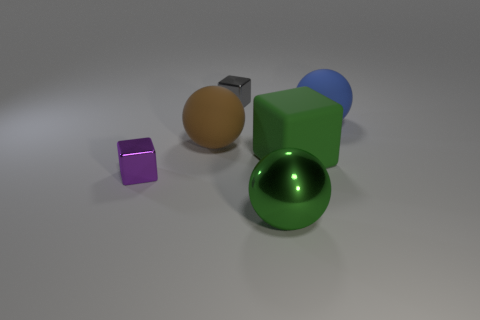Add 4 big red balls. How many objects exist? 10 Subtract all big green rubber blocks. How many blocks are left? 2 Subtract 2 blocks. How many blocks are left? 1 Subtract all gray blocks. Subtract all yellow cylinders. How many blocks are left? 2 Subtract all large cubes. Subtract all tiny purple things. How many objects are left? 4 Add 5 tiny shiny things. How many tiny shiny things are left? 7 Add 5 gray rubber cubes. How many gray rubber cubes exist? 5 Subtract all brown balls. How many balls are left? 2 Subtract 0 cyan cylinders. How many objects are left? 6 